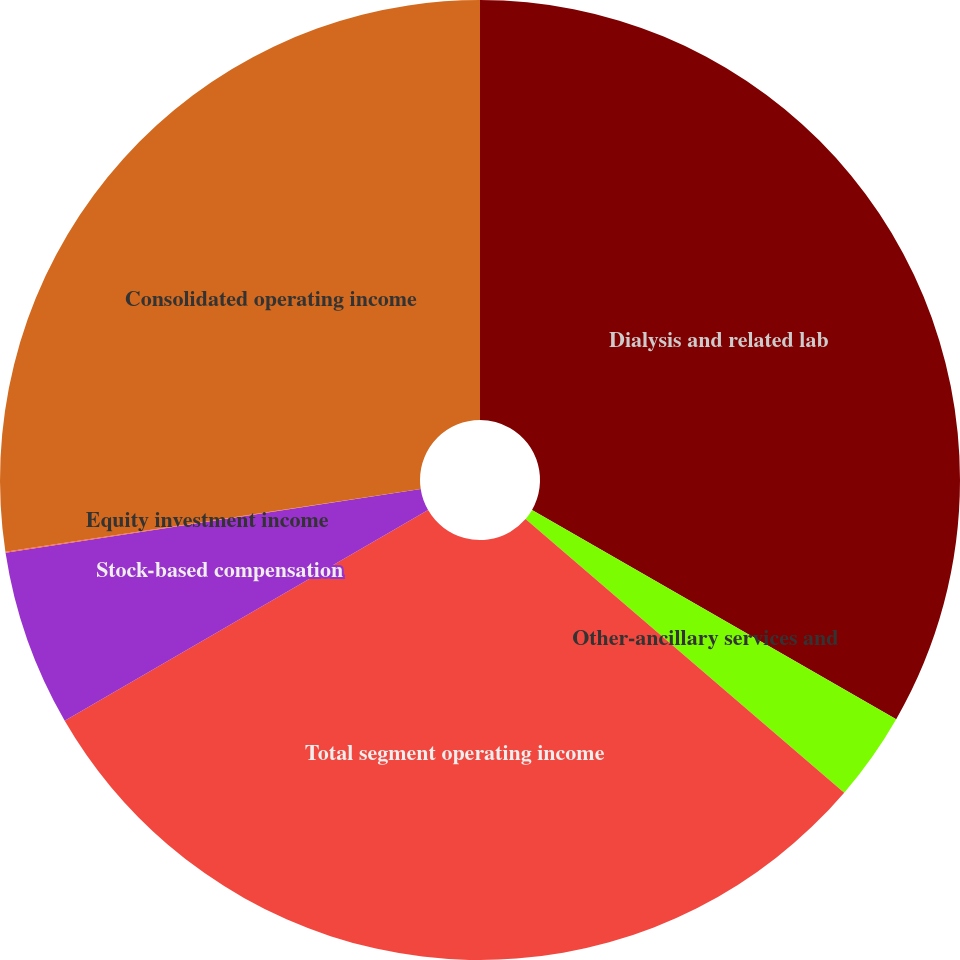Convert chart to OTSL. <chart><loc_0><loc_0><loc_500><loc_500><pie_chart><fcel>Dialysis and related lab<fcel>Other-ancillary services and<fcel>Total segment operating income<fcel>Stock-based compensation<fcel>Equity investment income<fcel>Consolidated operating income<nl><fcel>33.3%<fcel>2.99%<fcel>30.35%<fcel>5.94%<fcel>0.03%<fcel>27.39%<nl></chart> 